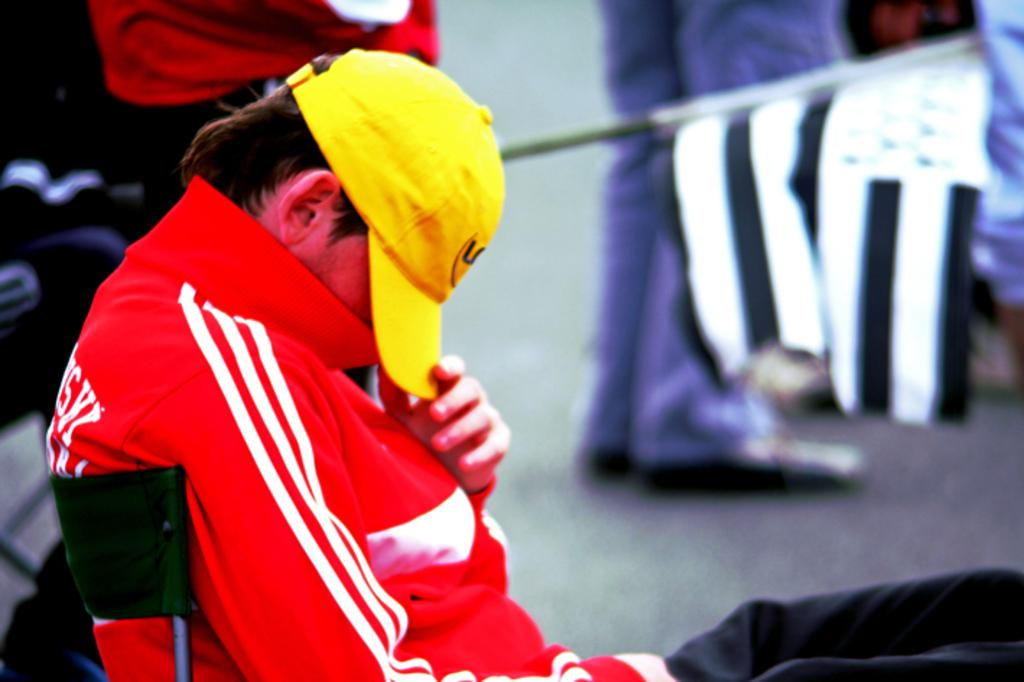What is the person in the image doing? The person is sitting on a chair in the image. What is the person wearing? The person is wearing a red dress and a yellow cap. Can you describe the people in the background of the image? There are people standing in the background of the image, and they are on a road. What type of chin can be seen on the beetle in the image? There is no beetle present in the image, so it is not possible to determine the type of chin on a beetle. 